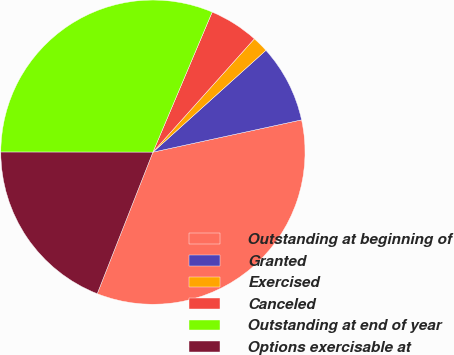Convert chart to OTSL. <chart><loc_0><loc_0><loc_500><loc_500><pie_chart><fcel>Outstanding at beginning of<fcel>Granted<fcel>Exercised<fcel>Canceled<fcel>Outstanding at end of year<fcel>Options exercisable at<nl><fcel>34.37%<fcel>8.27%<fcel>1.71%<fcel>5.25%<fcel>31.36%<fcel>19.05%<nl></chart> 